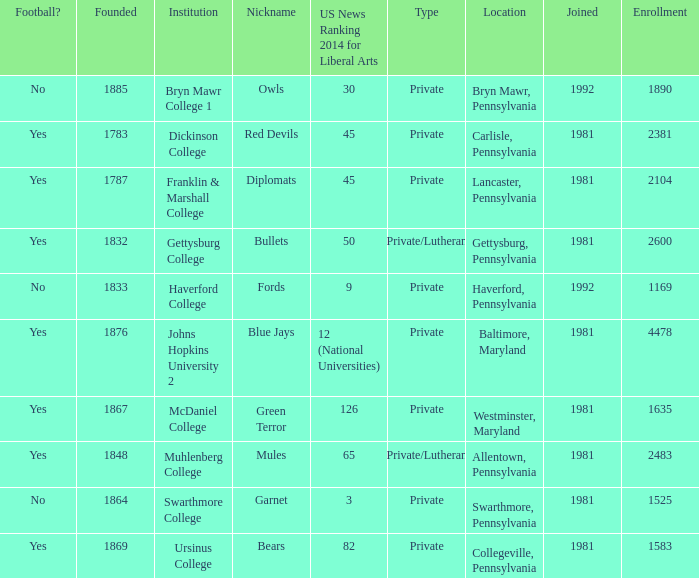When was Dickinson College founded? 1783.0. 